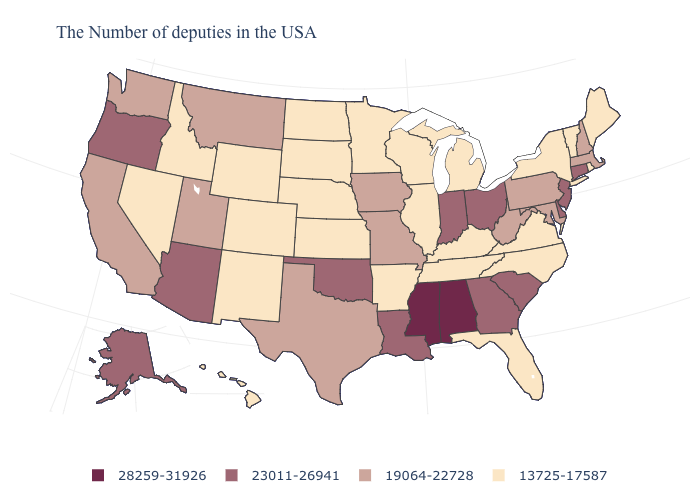How many symbols are there in the legend?
Give a very brief answer. 4. What is the value of Florida?
Quick response, please. 13725-17587. Name the states that have a value in the range 13725-17587?
Write a very short answer. Maine, Rhode Island, Vermont, New York, Virginia, North Carolina, Florida, Michigan, Kentucky, Tennessee, Wisconsin, Illinois, Arkansas, Minnesota, Kansas, Nebraska, South Dakota, North Dakota, Wyoming, Colorado, New Mexico, Idaho, Nevada, Hawaii. Does Tennessee have the highest value in the USA?
Write a very short answer. No. What is the lowest value in the USA?
Quick response, please. 13725-17587. What is the value of Arkansas?
Answer briefly. 13725-17587. Does the first symbol in the legend represent the smallest category?
Short answer required. No. How many symbols are there in the legend?
Keep it brief. 4. Name the states that have a value in the range 28259-31926?
Quick response, please. Alabama, Mississippi. What is the highest value in the Northeast ?
Give a very brief answer. 23011-26941. Which states have the lowest value in the South?
Give a very brief answer. Virginia, North Carolina, Florida, Kentucky, Tennessee, Arkansas. Name the states that have a value in the range 19064-22728?
Write a very short answer. Massachusetts, New Hampshire, Maryland, Pennsylvania, West Virginia, Missouri, Iowa, Texas, Utah, Montana, California, Washington. Name the states that have a value in the range 19064-22728?
Quick response, please. Massachusetts, New Hampshire, Maryland, Pennsylvania, West Virginia, Missouri, Iowa, Texas, Utah, Montana, California, Washington. What is the value of Colorado?
Give a very brief answer. 13725-17587. Name the states that have a value in the range 13725-17587?
Short answer required. Maine, Rhode Island, Vermont, New York, Virginia, North Carolina, Florida, Michigan, Kentucky, Tennessee, Wisconsin, Illinois, Arkansas, Minnesota, Kansas, Nebraska, South Dakota, North Dakota, Wyoming, Colorado, New Mexico, Idaho, Nevada, Hawaii. 